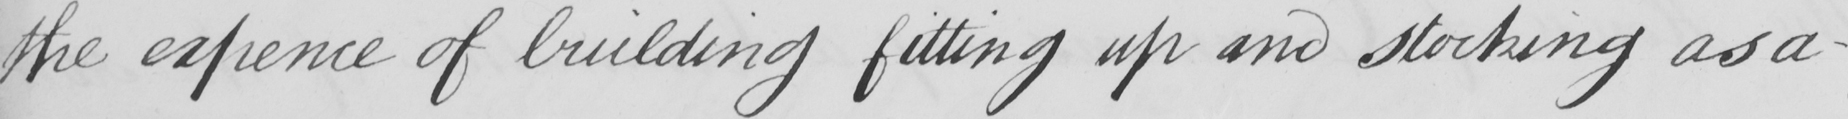What text is written in this handwritten line? the expence of building fitting up and stocking as a- 